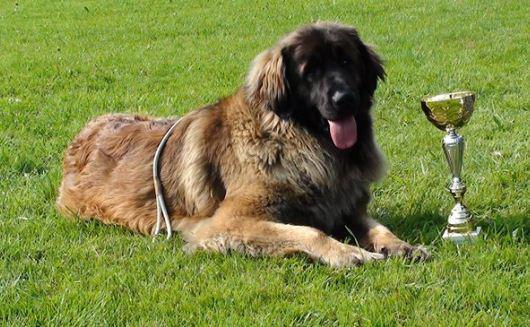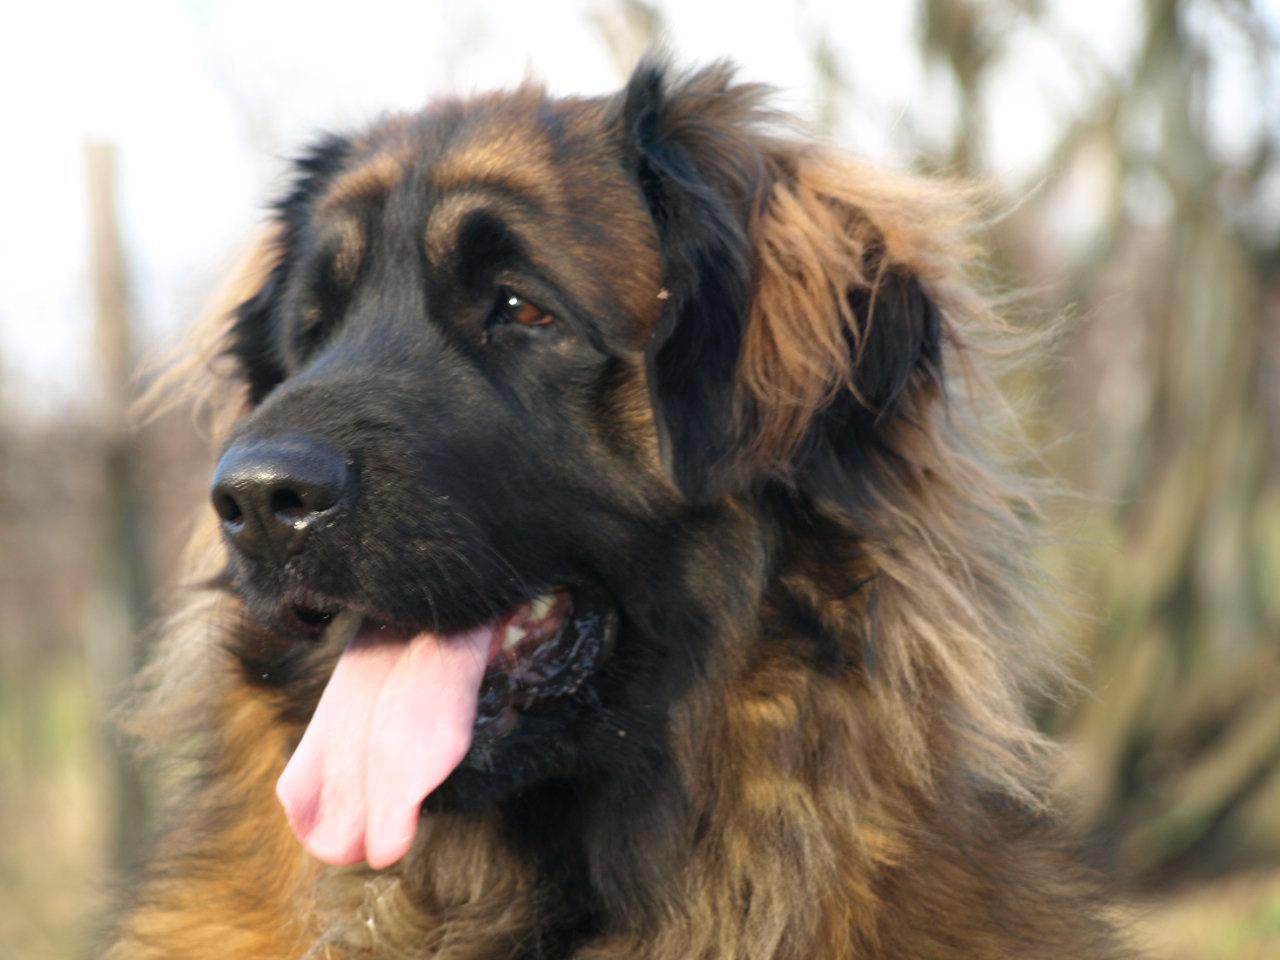The first image is the image on the left, the second image is the image on the right. For the images displayed, is the sentence "A trophy stands in the grass next to a dog in one image." factually correct? Answer yes or no. Yes. The first image is the image on the left, the second image is the image on the right. Given the left and right images, does the statement "In one of the images there is a large dog next to a trophy." hold true? Answer yes or no. Yes. 